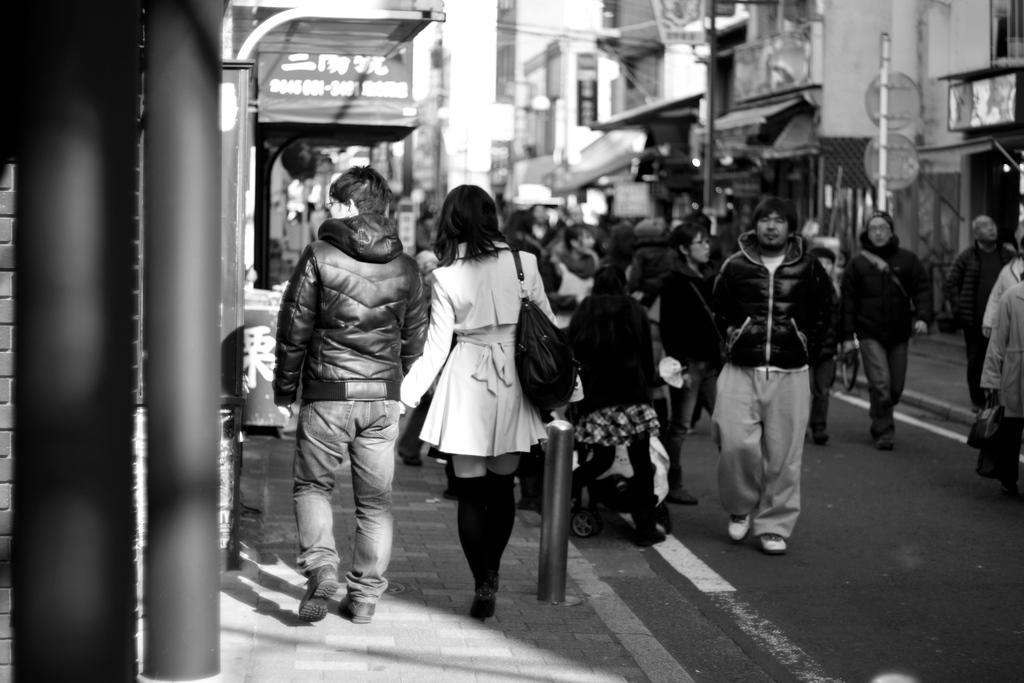What are the people in the image doing? The people in the image are walking on the road. What can be seen on the left side of the image? There are poles on the left side of the image. What can be seen on the right side of the image? There are poles on the right side of the image. What type of bike is being ridden by the person on the right side of the image? There is no person riding a bike in the image; the people are walking on the road. What hobbies do the people in the image have? The provided facts do not give any information about the hobbies of the people in the image. 